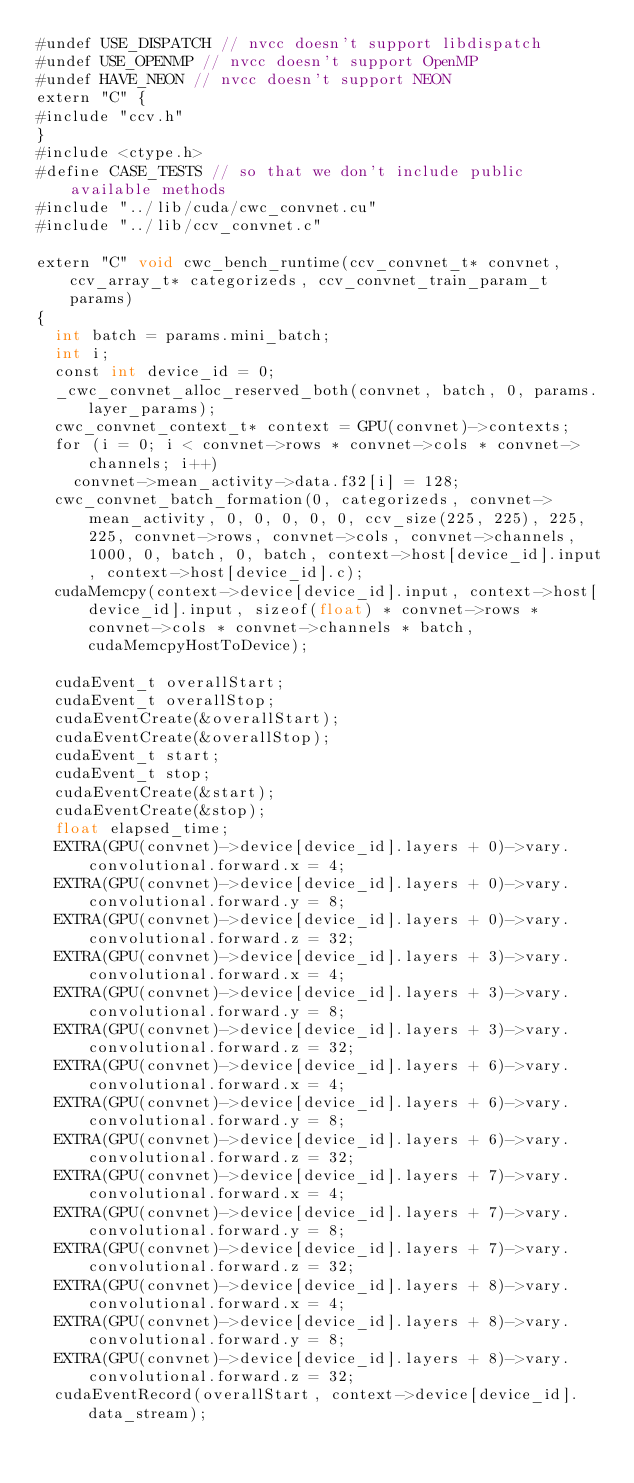<code> <loc_0><loc_0><loc_500><loc_500><_Cuda_>#undef USE_DISPATCH // nvcc doesn't support libdispatch
#undef USE_OPENMP // nvcc doesn't support OpenMP
#undef HAVE_NEON // nvcc doesn't support NEON
extern "C" {
#include "ccv.h"
}
#include <ctype.h>
#define CASE_TESTS // so that we don't include public available methods
#include "../lib/cuda/cwc_convnet.cu"
#include "../lib/ccv_convnet.c"

extern "C" void cwc_bench_runtime(ccv_convnet_t* convnet, ccv_array_t* categorizeds, ccv_convnet_train_param_t params)
{
	int batch = params.mini_batch;
	int i;
	const int device_id = 0;
	_cwc_convnet_alloc_reserved_both(convnet, batch, 0, params.layer_params);
	cwc_convnet_context_t* context = GPU(convnet)->contexts;
	for (i = 0; i < convnet->rows * convnet->cols * convnet->channels; i++)
		convnet->mean_activity->data.f32[i] = 128;
	cwc_convnet_batch_formation(0, categorizeds, convnet->mean_activity, 0, 0, 0, 0, 0, ccv_size(225, 225), 225, 225, convnet->rows, convnet->cols, convnet->channels, 1000, 0, batch, 0, batch, context->host[device_id].input, context->host[device_id].c);
	cudaMemcpy(context->device[device_id].input, context->host[device_id].input, sizeof(float) * convnet->rows * convnet->cols * convnet->channels * batch, cudaMemcpyHostToDevice);

	cudaEvent_t overallStart;
	cudaEvent_t overallStop;
	cudaEventCreate(&overallStart);
	cudaEventCreate(&overallStop);
	cudaEvent_t start;
	cudaEvent_t stop;
	cudaEventCreate(&start);
	cudaEventCreate(&stop);
	float elapsed_time;
	EXTRA(GPU(convnet)->device[device_id].layers + 0)->vary.convolutional.forward.x = 4;
	EXTRA(GPU(convnet)->device[device_id].layers + 0)->vary.convolutional.forward.y = 8;
	EXTRA(GPU(convnet)->device[device_id].layers + 0)->vary.convolutional.forward.z = 32;
	EXTRA(GPU(convnet)->device[device_id].layers + 3)->vary.convolutional.forward.x = 4;
	EXTRA(GPU(convnet)->device[device_id].layers + 3)->vary.convolutional.forward.y = 8;
	EXTRA(GPU(convnet)->device[device_id].layers + 3)->vary.convolutional.forward.z = 32;
	EXTRA(GPU(convnet)->device[device_id].layers + 6)->vary.convolutional.forward.x = 4;
	EXTRA(GPU(convnet)->device[device_id].layers + 6)->vary.convolutional.forward.y = 8;
	EXTRA(GPU(convnet)->device[device_id].layers + 6)->vary.convolutional.forward.z = 32;
	EXTRA(GPU(convnet)->device[device_id].layers + 7)->vary.convolutional.forward.x = 4;
	EXTRA(GPU(convnet)->device[device_id].layers + 7)->vary.convolutional.forward.y = 8;
	EXTRA(GPU(convnet)->device[device_id].layers + 7)->vary.convolutional.forward.z = 32;
	EXTRA(GPU(convnet)->device[device_id].layers + 8)->vary.convolutional.forward.x = 4;
	EXTRA(GPU(convnet)->device[device_id].layers + 8)->vary.convolutional.forward.y = 8;
	EXTRA(GPU(convnet)->device[device_id].layers + 8)->vary.convolutional.forward.z = 32;
	cudaEventRecord(overallStart, context->device[device_id].data_stream);</code> 